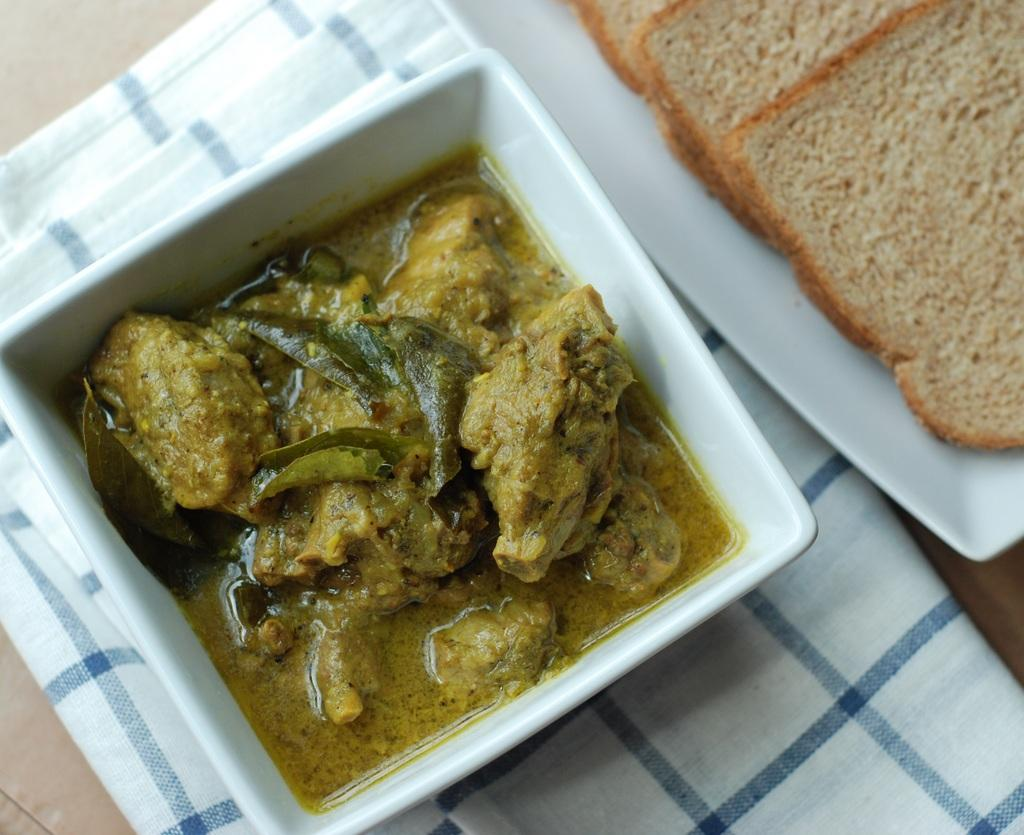What type of food is in the bowl in the image? There is curry served in a bowl in the image. What is located beside the bowl? There is a plate beside the bowl. What is on the plate? There are bread slices on the plate. What type of beam can be seen supporting the bed in the image? There is no bed or beam present in the image; it features a bowl of curry and a plate of bread slices. 